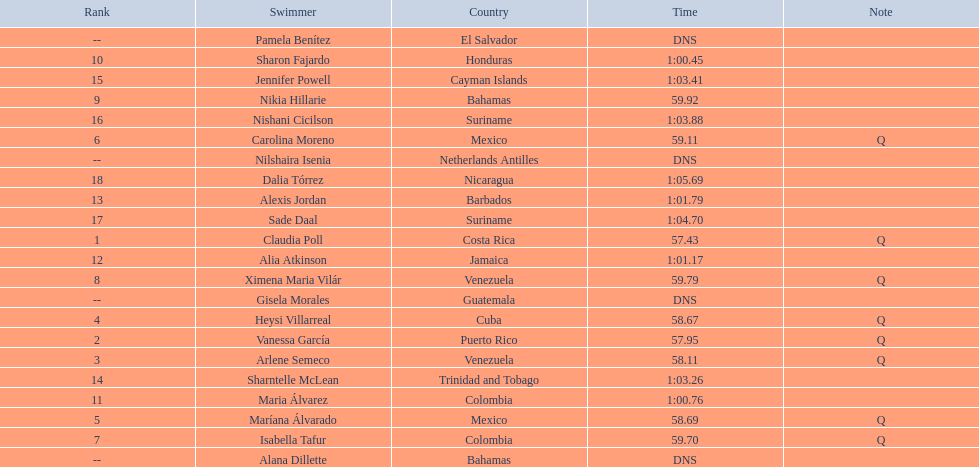Who were the swimmers at the 2006 central american and caribbean games - women's 100 metre freestyle? Claudia Poll, Vanessa García, Arlene Semeco, Heysi Villarreal, Maríana Álvarado, Carolina Moreno, Isabella Tafur, Ximena Maria Vilár, Nikia Hillarie, Sharon Fajardo, Maria Álvarez, Alia Atkinson, Alexis Jordan, Sharntelle McLean, Jennifer Powell, Nishani Cicilson, Sade Daal, Dalia Tórrez, Gisela Morales, Alana Dillette, Pamela Benítez, Nilshaira Isenia. Of these which were from cuba? Heysi Villarreal. Parse the full table. {'header': ['Rank', 'Swimmer', 'Country', 'Time', 'Note'], 'rows': [['--', 'Pamela Benítez', 'El Salvador', 'DNS', ''], ['10', 'Sharon Fajardo', 'Honduras', '1:00.45', ''], ['15', 'Jennifer Powell', 'Cayman Islands', '1:03.41', ''], ['9', 'Nikia Hillarie', 'Bahamas', '59.92', ''], ['16', 'Nishani Cicilson', 'Suriname', '1:03.88', ''], ['6', 'Carolina Moreno', 'Mexico', '59.11', 'Q'], ['--', 'Nilshaira Isenia', 'Netherlands Antilles', 'DNS', ''], ['18', 'Dalia Tórrez', 'Nicaragua', '1:05.69', ''], ['13', 'Alexis Jordan', 'Barbados', '1:01.79', ''], ['17', 'Sade Daal', 'Suriname', '1:04.70', ''], ['1', 'Claudia Poll', 'Costa Rica', '57.43', 'Q'], ['12', 'Alia Atkinson', 'Jamaica', '1:01.17', ''], ['8', 'Ximena Maria Vilár', 'Venezuela', '59.79', 'Q'], ['--', 'Gisela Morales', 'Guatemala', 'DNS', ''], ['4', 'Heysi Villarreal', 'Cuba', '58.67', 'Q'], ['2', 'Vanessa García', 'Puerto Rico', '57.95', 'Q'], ['3', 'Arlene Semeco', 'Venezuela', '58.11', 'Q'], ['14', 'Sharntelle McLean', 'Trinidad and Tobago', '1:03.26', ''], ['11', 'Maria Álvarez', 'Colombia', '1:00.76', ''], ['5', 'Maríana Álvarado', 'Mexico', '58.69', 'Q'], ['7', 'Isabella Tafur', 'Colombia', '59.70', 'Q'], ['--', 'Alana Dillette', 'Bahamas', 'DNS', '']]} 